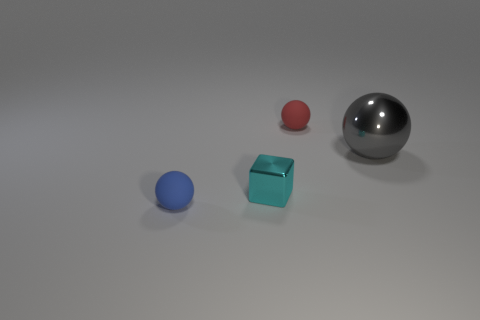Is there a metal block of the same size as the red ball?
Your answer should be compact. Yes. What is the color of the ball that is made of the same material as the cube?
Provide a short and direct response. Gray. What number of rubber balls are in front of the tiny sphere that is behind the blue matte sphere?
Provide a short and direct response. 1. There is a ball that is on the left side of the large shiny object and in front of the small red thing; what is its material?
Ensure brevity in your answer.  Rubber. There is a blue thing that is in front of the cyan shiny block; is it the same shape as the large thing?
Provide a succinct answer. Yes. Is the number of green cylinders less than the number of rubber things?
Your answer should be compact. Yes. Is the number of red objects greater than the number of matte things?
Give a very brief answer. No. There is another metallic thing that is the same shape as the small red thing; what size is it?
Keep it short and to the point. Large. Do the tiny blue thing and the tiny cyan thing that is left of the big metallic thing have the same material?
Provide a succinct answer. No. What number of objects are either big metal objects or cyan metal spheres?
Offer a terse response. 1. 